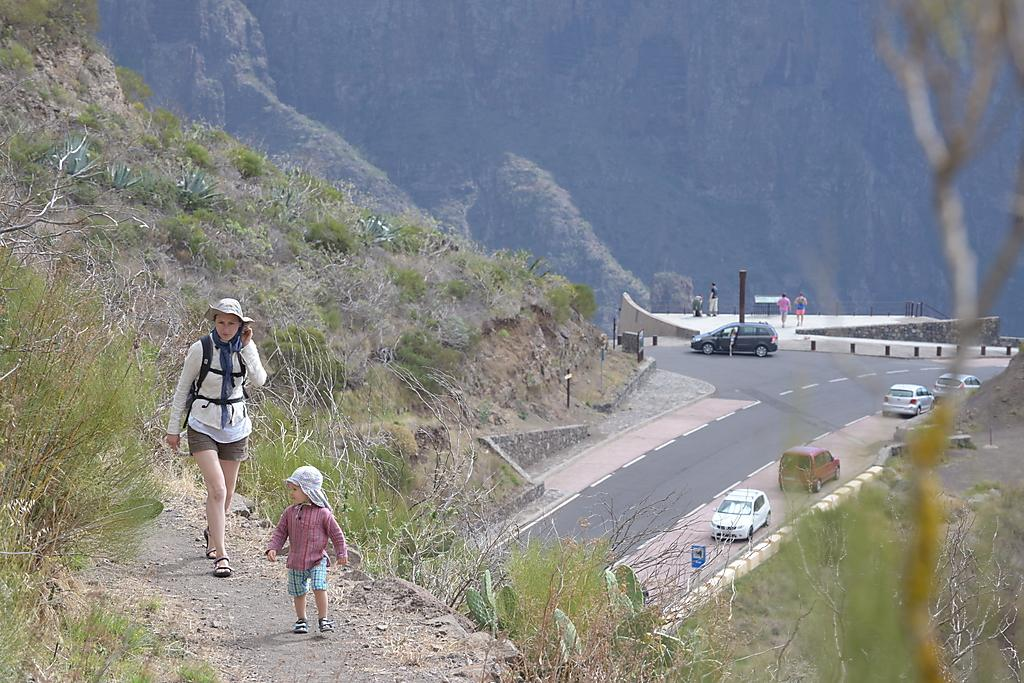Who can be seen in the foreground of the image? There is a lady and a small girl in the foreground of the image. What are the lady and the small girl doing in the image? The lady and the small girl are walking. What can be seen in the background of the image? There are vehicles, poles, people, and mountains in the background of the image. What industry is the lady and the small girl involved in, as seen in the image? There is no indication of any industry in the image; it simply shows a lady and a small girl walking. 